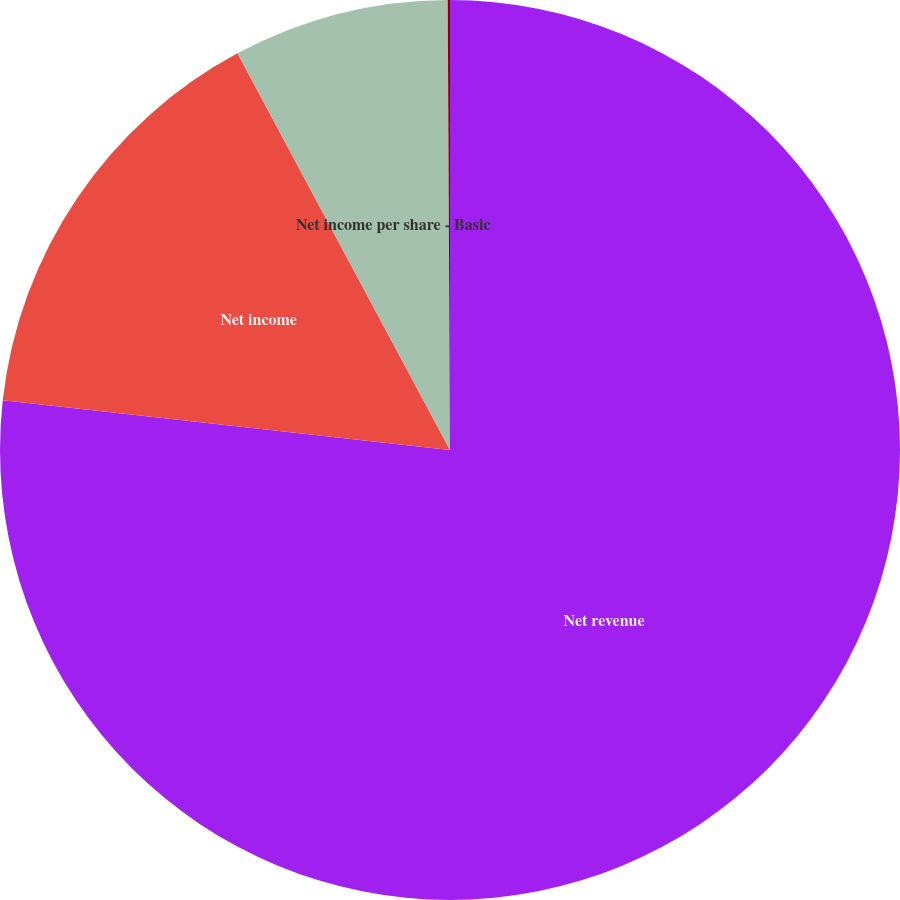Convert chart. <chart><loc_0><loc_0><loc_500><loc_500><pie_chart><fcel>Net revenue<fcel>Net income<fcel>Net income per share - Basic<fcel>Net income per share - Diluted<nl><fcel>76.76%<fcel>15.41%<fcel>7.75%<fcel>0.08%<nl></chart> 